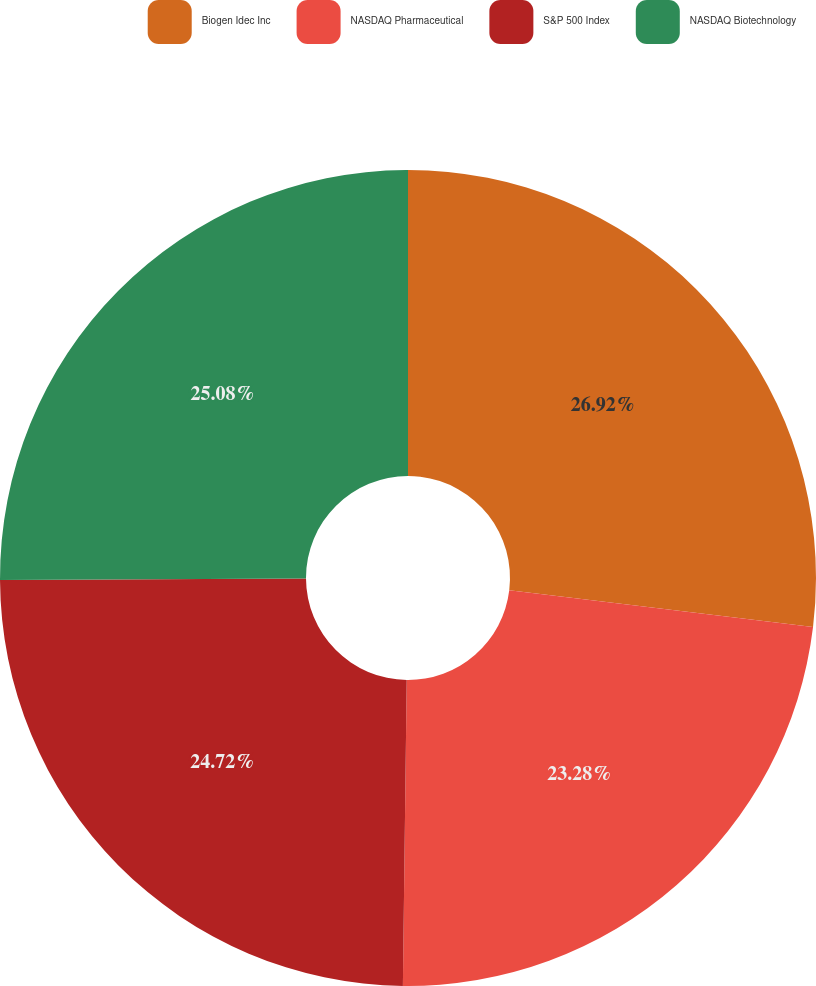Convert chart to OTSL. <chart><loc_0><loc_0><loc_500><loc_500><pie_chart><fcel>Biogen Idec Inc<fcel>NASDAQ Pharmaceutical<fcel>S&P 500 Index<fcel>NASDAQ Biotechnology<nl><fcel>26.92%<fcel>23.28%<fcel>24.72%<fcel>25.08%<nl></chart> 